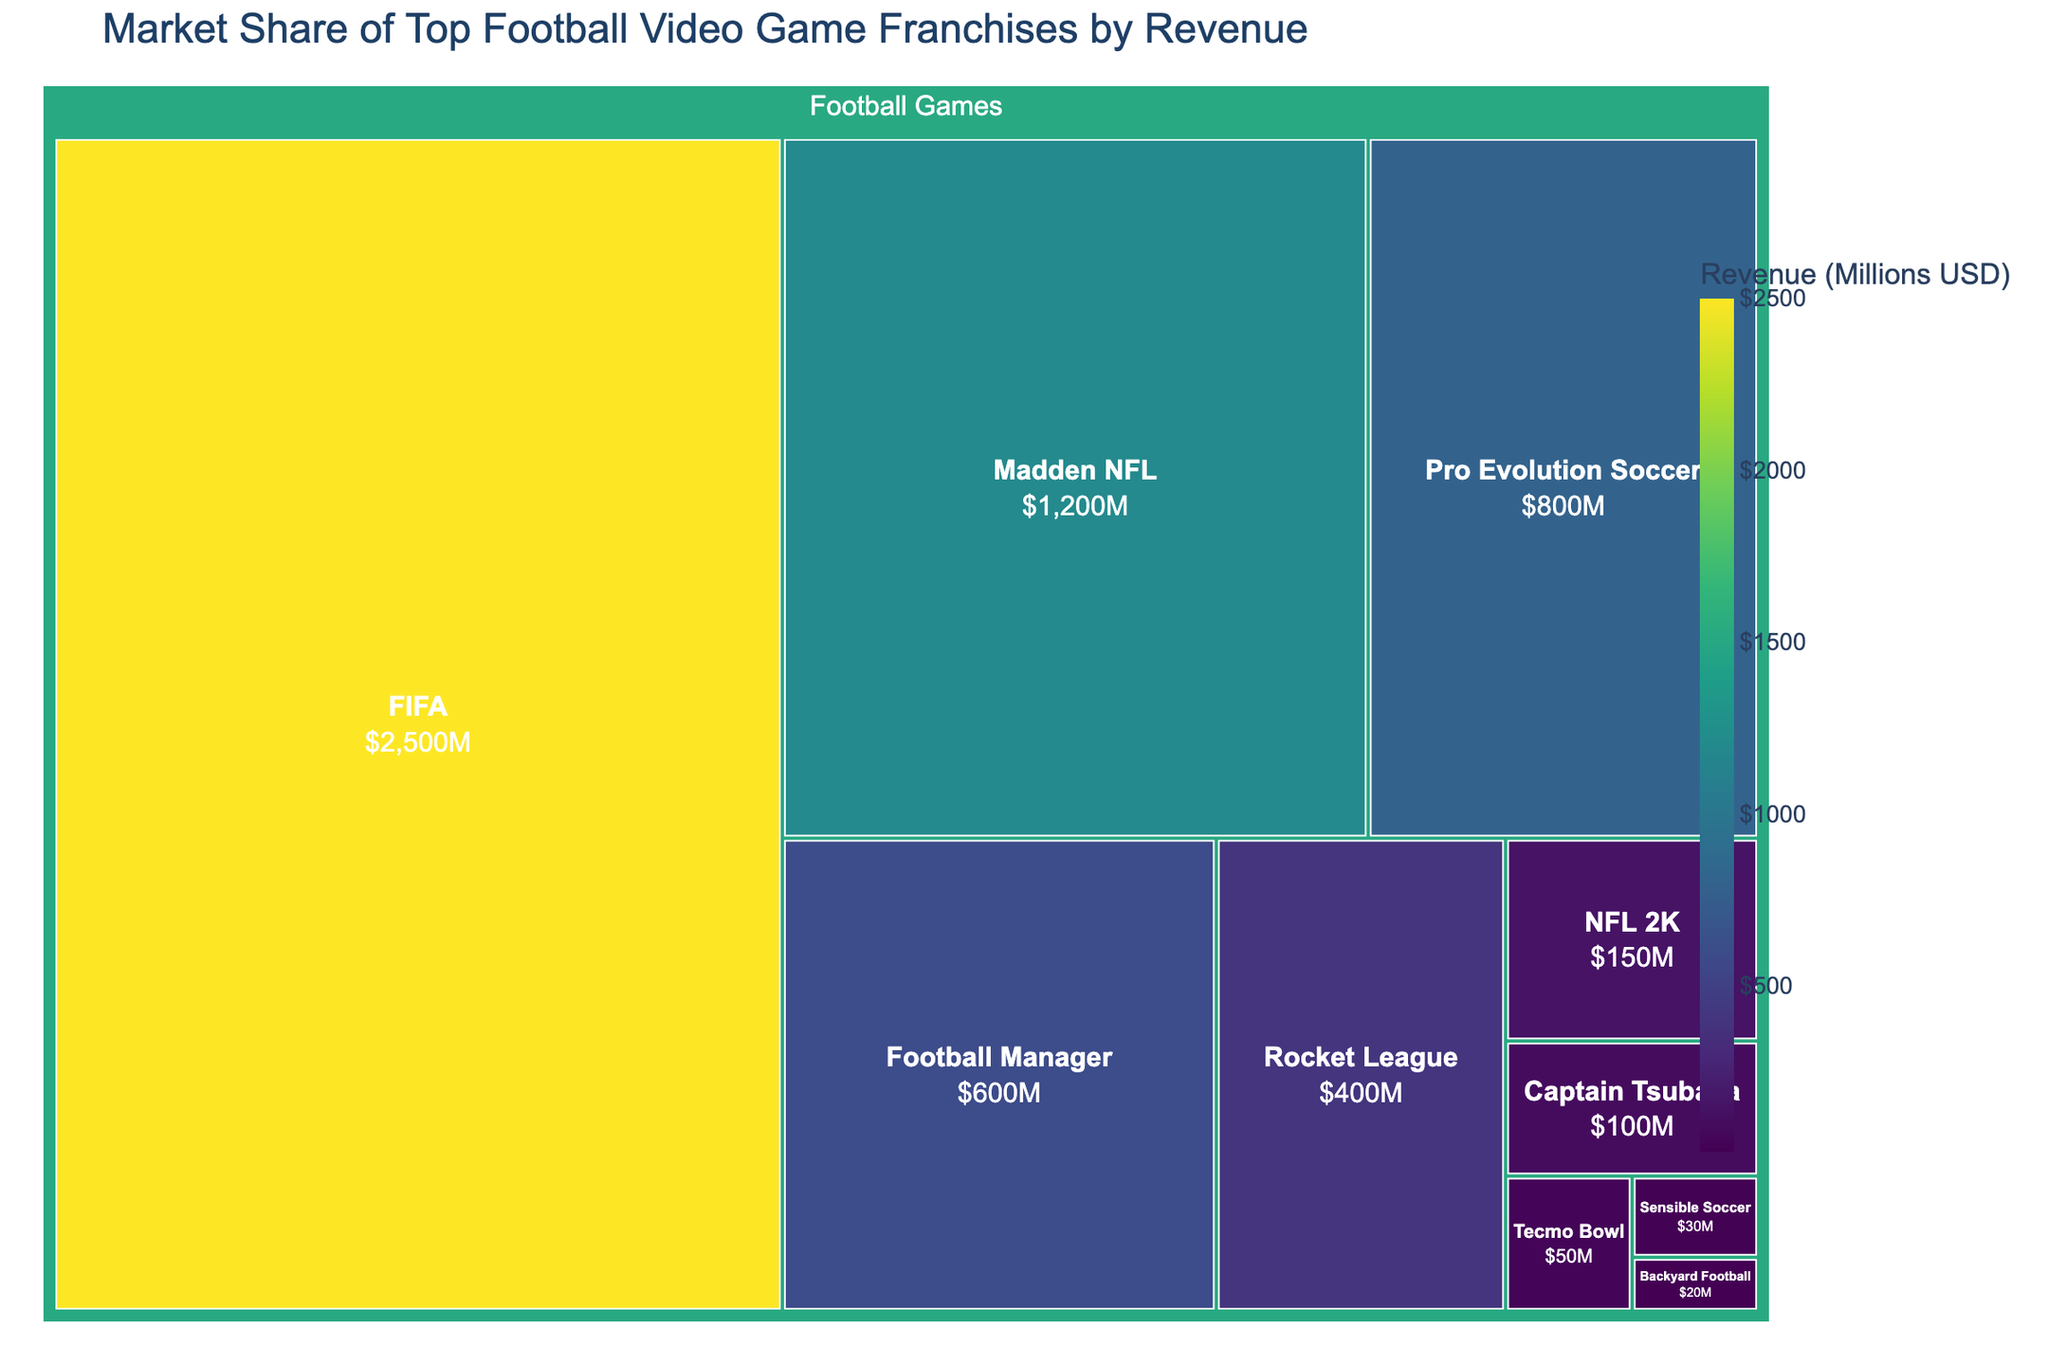How much revenue does the FIFA franchise generate? The treemap shows the revenue for each football game franchise. Locate the FIFA section to find its revenue.
Answer: $2500M Which franchise has the least revenue? The treemap displays all franchises with their revenue. Identify the smallest section, which represents the franchise with the least revenue.
Answer: Backyard Football How much more revenue does FIFA generate compared to Pro Evolution Soccer? Locate the revenue for both FIFA and Pro Evolution Soccer from the treemap. Subtract Pro Evolution Soccer's revenue from FIFA's revenue: $2500M - $800M = $1700M.
Answer: $1700M What is the total revenue generated by NFL-based games (Madden NFL and NFL 2K)? Identify the revenue for Madden NFL and NFL 2K. Add their revenue: $1200M + $150M = $1350M.
Answer: $1350M Which three franchises have the highest revenue? Examine the treemap to find the three largest sections. These sections represent the franchises with the highest revenue.
Answer: FIFA, Madden NFL, Pro Evolution Soccer How does Rocket League's revenue compare to that of Football Manager? Find the revenue values for Rocket League and Football Manager from the treemap. Compare the numbers: Rocket League's revenue is $400M, while Football Manager's revenue is $600M.
Answer: Lower What is the combined revenue of franchises making less than $200M in revenue? Identify the franchises with less than $200M in revenue: NFL 2K, Tecmo Bowl, Sensible Soccer, Backyard Football, Captain Tsubasa. Add their revenue: $150M + $50M + $30M + $20M + $100M = $350M.
Answer: $350M What proportion of the total revenue does FIFA account for? The total revenue from all franchises can be calculated by adding their revenues: 2500 + 800 + 600 + 1200 + 150 + 50 + 400 + 30 + 20 + 100 = $5850M. FIFA's revenue is $2500M. Calculate the proportion: ($2500M / $5850M) * 100 ≈ 42.74%.
Answer: ~42.74% If Madden NFL and FIFA's revenue are combined, what percentage of the total market share would they hold? Calculate the combined revenue: $2500M + $1200M = $3700M. Then, calculate the percentage of the total: ($3700M / $5850M) * 100 ≈ 63.25%.
Answer: ~63.25% How many franchises have a revenue below $100M? Examine the treemap for franchise revenues under $100M: Tecmo Bowl, Sensible Soccer, Backyard Football, and Captain Tsubasa. Count these franchises.
Answer: 4 